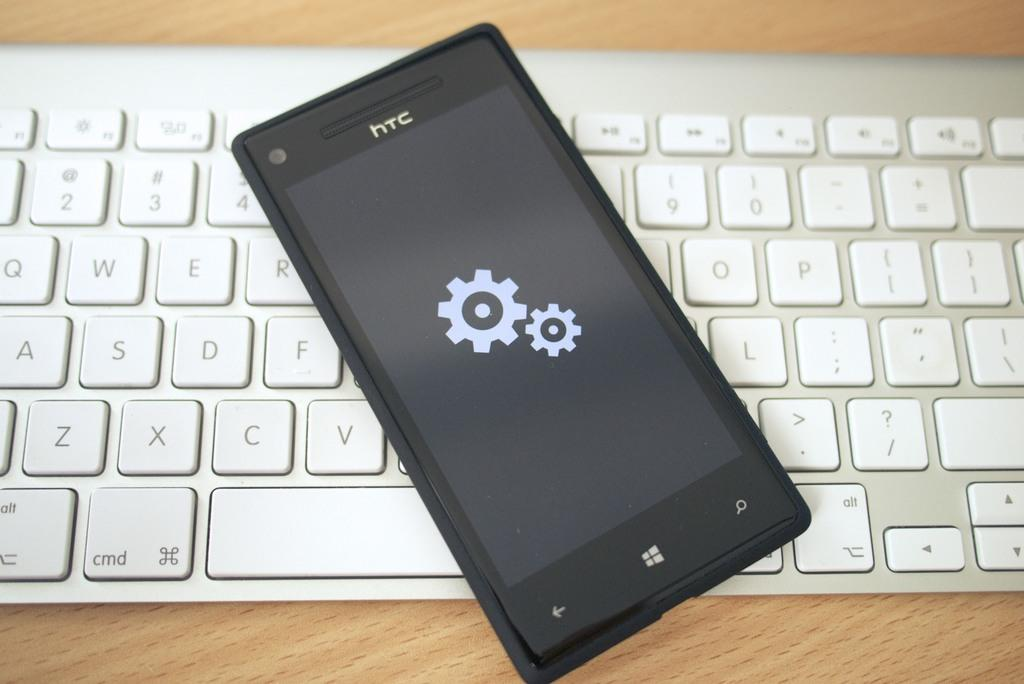<image>
Create a compact narrative representing the image presented. A black htc phone lays on top of a keyboard. 